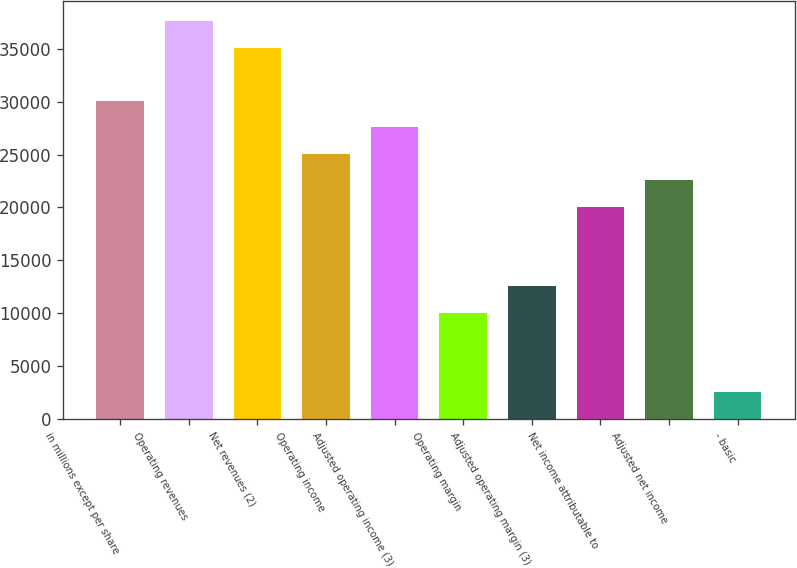<chart> <loc_0><loc_0><loc_500><loc_500><bar_chart><fcel>in millions except per share<fcel>Operating revenues<fcel>Net revenues (2)<fcel>Operating income<fcel>Adjusted operating income (3)<fcel>Operating margin<fcel>Adjusted operating margin (3)<fcel>Net income attributable to<fcel>Adjusted net income<fcel>- basic<nl><fcel>30087.6<fcel>37609.2<fcel>35102<fcel>25073.2<fcel>27580.4<fcel>10029.9<fcel>12537.1<fcel>20058.7<fcel>22566<fcel>2508.27<nl></chart> 